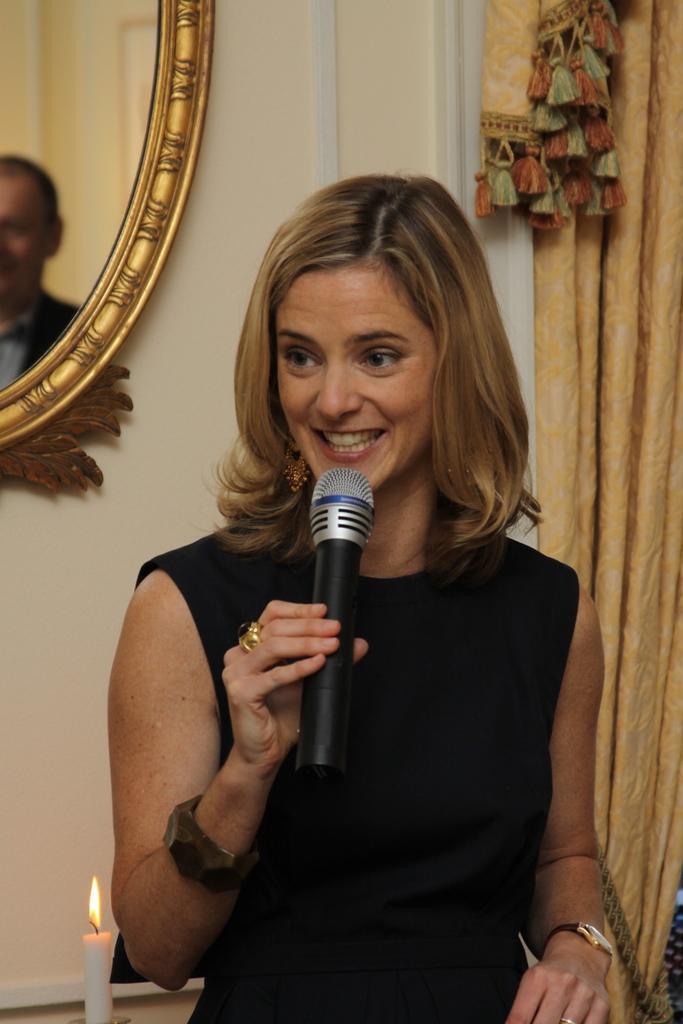Describe this image in one or two sentences. This is the picture of a woman in black dress holding a microphone and talking something and to her left hand she is wearing a watch. Behind the woman there is a wall with mirror and curtain and also on the table there is a candle with flame. 